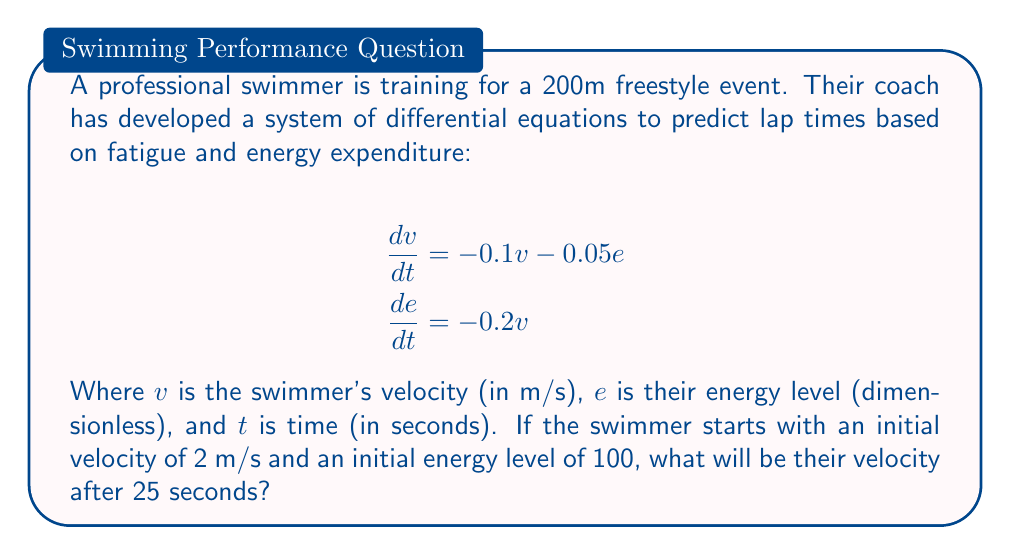Help me with this question. To solve this system of differential equations, we'll use the following steps:

1) First, we need to solve for $e$ in terms of $v$:
   From $\frac{de}{dt} = -0.2v$, we can integrate both sides:
   $$e = -0.2\int v dt + C$$

2) Now, substitute this into the first equation:
   $$\frac{dv}{dt} = -0.1v - 0.05(-0.2\int v dt + C)$$
   $$\frac{dv}{dt} = -0.1v + 0.01\int v dt - 0.05C$$

3) Differentiate both sides with respect to $t$:
   $$\frac{d^2v}{dt^2} = -0.1\frac{dv}{dt} + 0.01v$$

4) This is a second-order linear differential equation. The characteristic equation is:
   $$r^2 + 0.1r - 0.01 = 0$$

5) Solving this quadratic equation:
   $$r = \frac{-0.1 \pm \sqrt{0.01 + 0.04}}{2} = -0.05 \pm 0.1$$

6) Therefore, the general solution is:
   $$v(t) = C_1e^{-0.15t} + C_2e^{0.05t}$$

7) Using the initial conditions:
   At $t=0$, $v=2$ and $e=100$
   $$2 = C_1 + C_2$$
   $$100 = -0.2(-\frac{C_1}{0.15} + \frac{C_2}{0.05})$$

8) Solving this system of equations:
   $$C_1 \approx 1.5385$$
   $$C_2 \approx 0.4615$$

9) Therefore, the velocity function is:
   $$v(t) \approx 1.5385e^{-0.15t} + 0.4615e^{0.05t}$$

10) Evaluating at $t=25$:
    $$v(25) \approx 1.5385e^{-0.15(25)} + 0.4615e^{0.05(25)} \approx 0.9415$$
Answer: 0.9415 m/s 